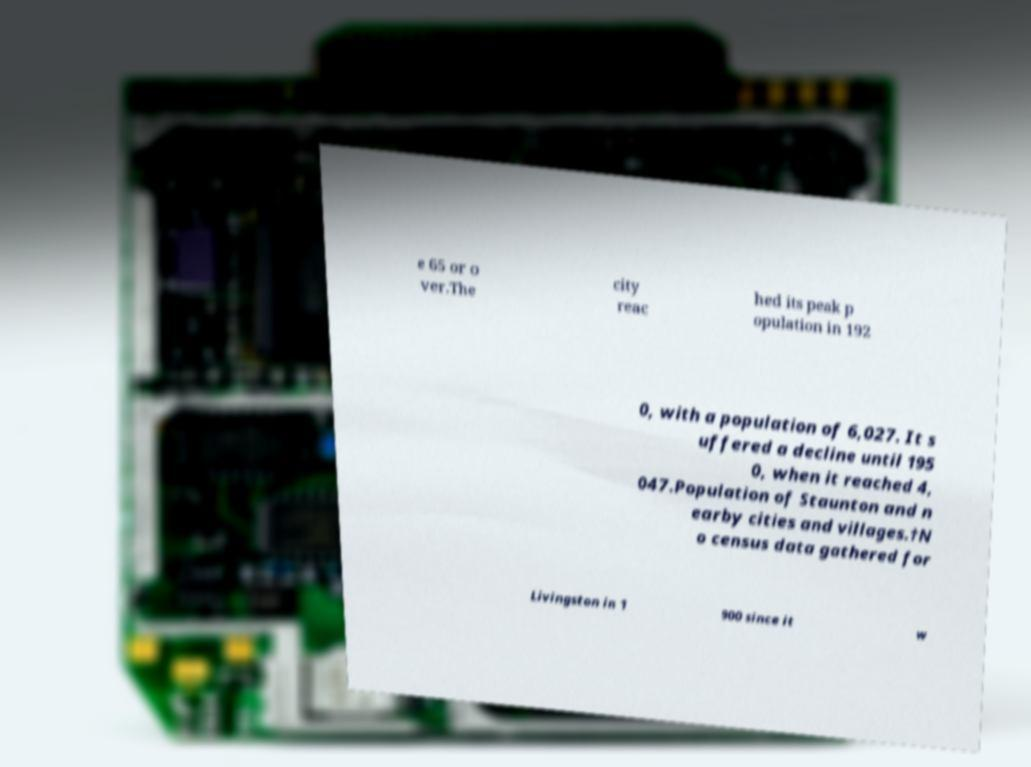Please read and relay the text visible in this image. What does it say? e 65 or o ver.The city reac hed its peak p opulation in 192 0, with a population of 6,027. It s uffered a decline until 195 0, when it reached 4, 047.Population of Staunton and n earby cities and villages.†N o census data gathered for Livingston in 1 900 since it w 